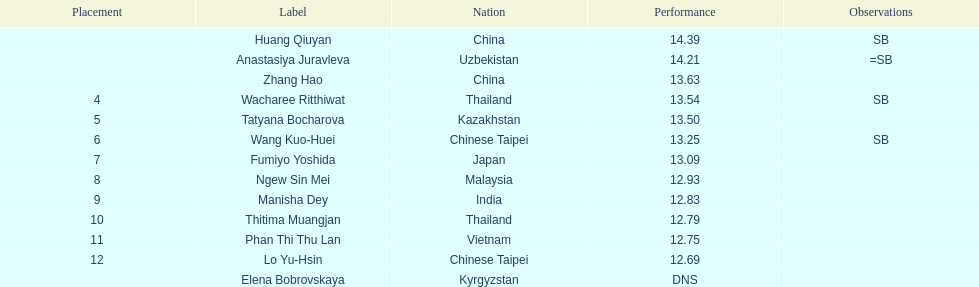What is the number of different nationalities represented by the top 5 athletes? 4. Would you be able to parse every entry in this table? {'header': ['Placement', 'Label', 'Nation', 'Performance', 'Observations'], 'rows': [['', 'Huang Qiuyan', 'China', '14.39', 'SB'], ['', 'Anastasiya Juravleva', 'Uzbekistan', '14.21', '=SB'], ['', 'Zhang Hao', 'China', '13.63', ''], ['4', 'Wacharee Ritthiwat', 'Thailand', '13.54', 'SB'], ['5', 'Tatyana Bocharova', 'Kazakhstan', '13.50', ''], ['6', 'Wang Kuo-Huei', 'Chinese Taipei', '13.25', 'SB'], ['7', 'Fumiyo Yoshida', 'Japan', '13.09', ''], ['8', 'Ngew Sin Mei', 'Malaysia', '12.93', ''], ['9', 'Manisha Dey', 'India', '12.83', ''], ['10', 'Thitima Muangjan', 'Thailand', '12.79', ''], ['11', 'Phan Thi Thu Lan', 'Vietnam', '12.75', ''], ['12', 'Lo Yu-Hsin', 'Chinese Taipei', '12.69', ''], ['', 'Elena Bobrovskaya', 'Kyrgyzstan', 'DNS', '']]} 